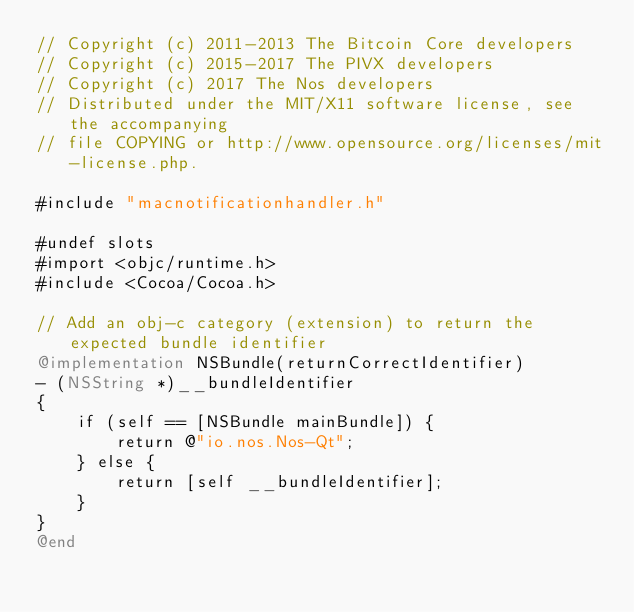Convert code to text. <code><loc_0><loc_0><loc_500><loc_500><_ObjectiveC_>// Copyright (c) 2011-2013 The Bitcoin Core developers
// Copyright (c) 2015-2017 The PIVX developers
// Copyright (c) 2017 The Nos developers
// Distributed under the MIT/X11 software license, see the accompanying
// file COPYING or http://www.opensource.org/licenses/mit-license.php.

#include "macnotificationhandler.h"

#undef slots
#import <objc/runtime.h>
#include <Cocoa/Cocoa.h>

// Add an obj-c category (extension) to return the expected bundle identifier
@implementation NSBundle(returnCorrectIdentifier)
- (NSString *)__bundleIdentifier
{
    if (self == [NSBundle mainBundle]) {
        return @"io.nos.Nos-Qt";
    } else {
        return [self __bundleIdentifier];
    }
}
@end
</code> 